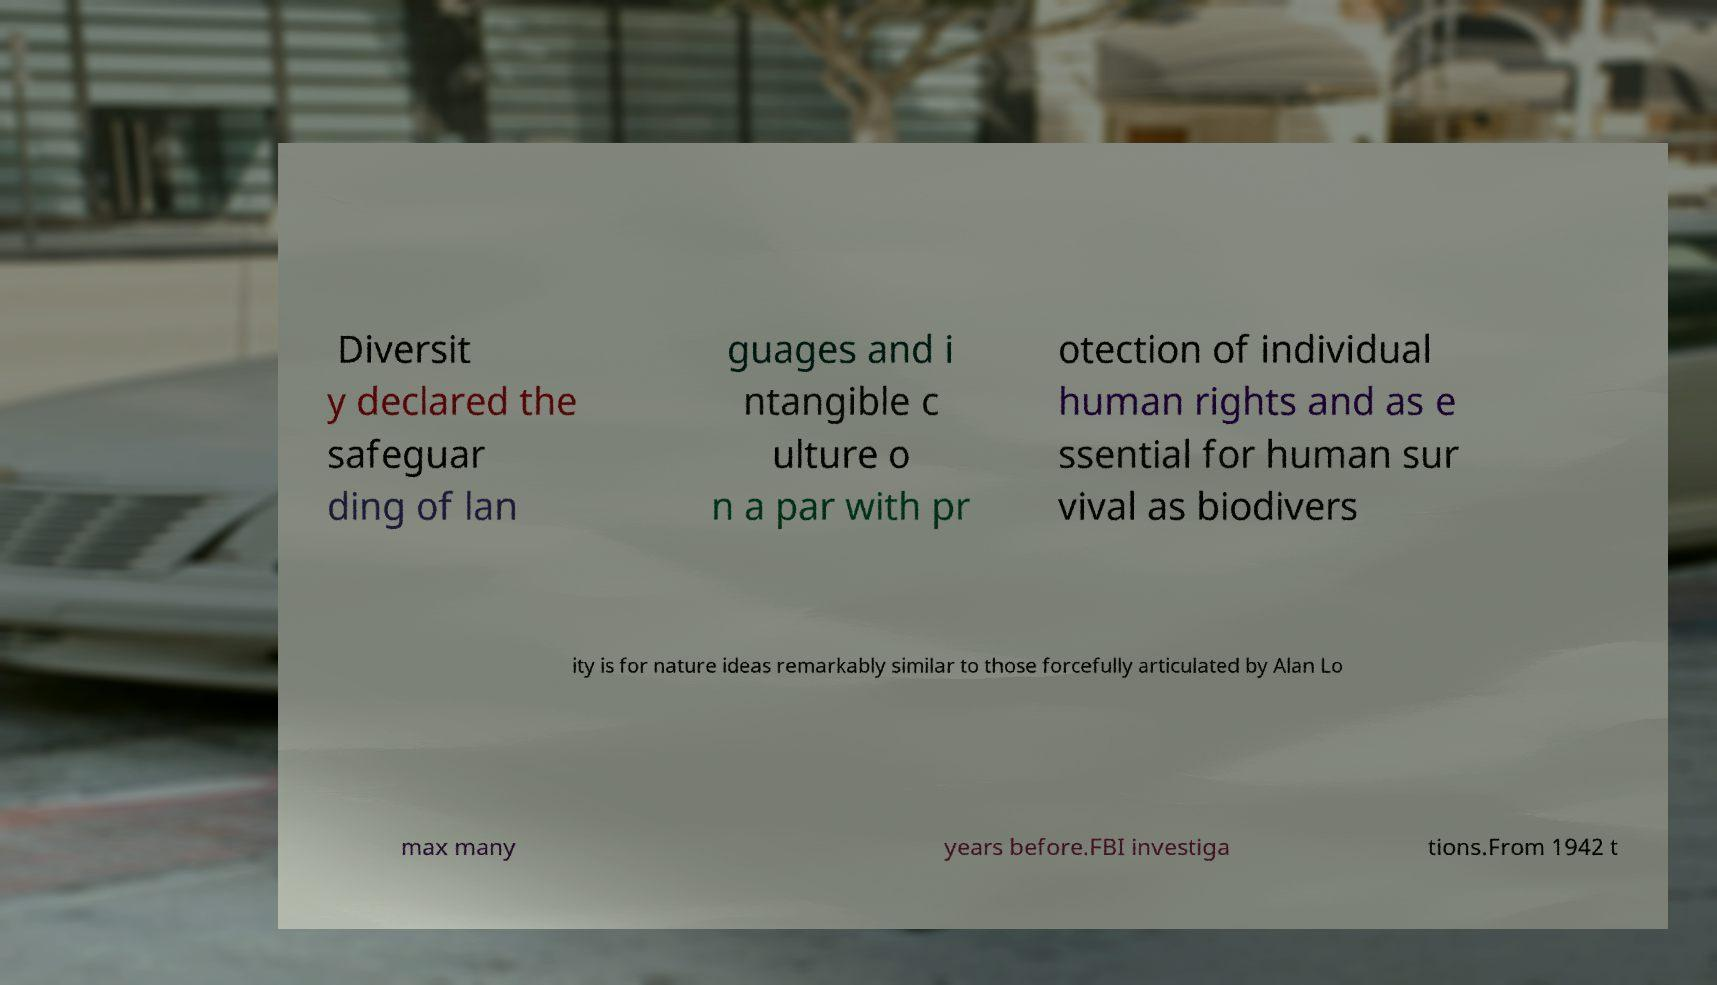What messages or text are displayed in this image? I need them in a readable, typed format. Diversit y declared the safeguar ding of lan guages and i ntangible c ulture o n a par with pr otection of individual human rights and as e ssential for human sur vival as biodivers ity is for nature ideas remarkably similar to those forcefully articulated by Alan Lo max many years before.FBI investiga tions.From 1942 t 